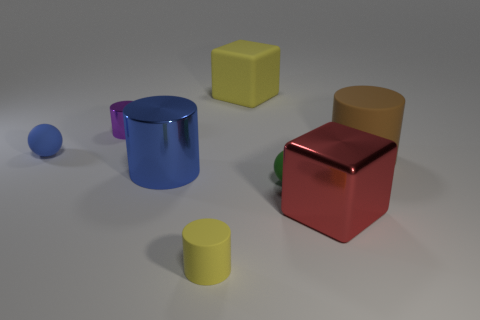Add 1 blue shiny spheres. How many objects exist? 9 Subtract all purple cylinders. How many cylinders are left? 3 Subtract all balls. How many objects are left? 6 Subtract all large blue metal cubes. Subtract all large cylinders. How many objects are left? 6 Add 6 purple objects. How many purple objects are left? 7 Add 7 large blue metallic cylinders. How many large blue metallic cylinders exist? 8 Subtract 1 blue balls. How many objects are left? 7 Subtract all yellow cylinders. Subtract all gray balls. How many cylinders are left? 3 